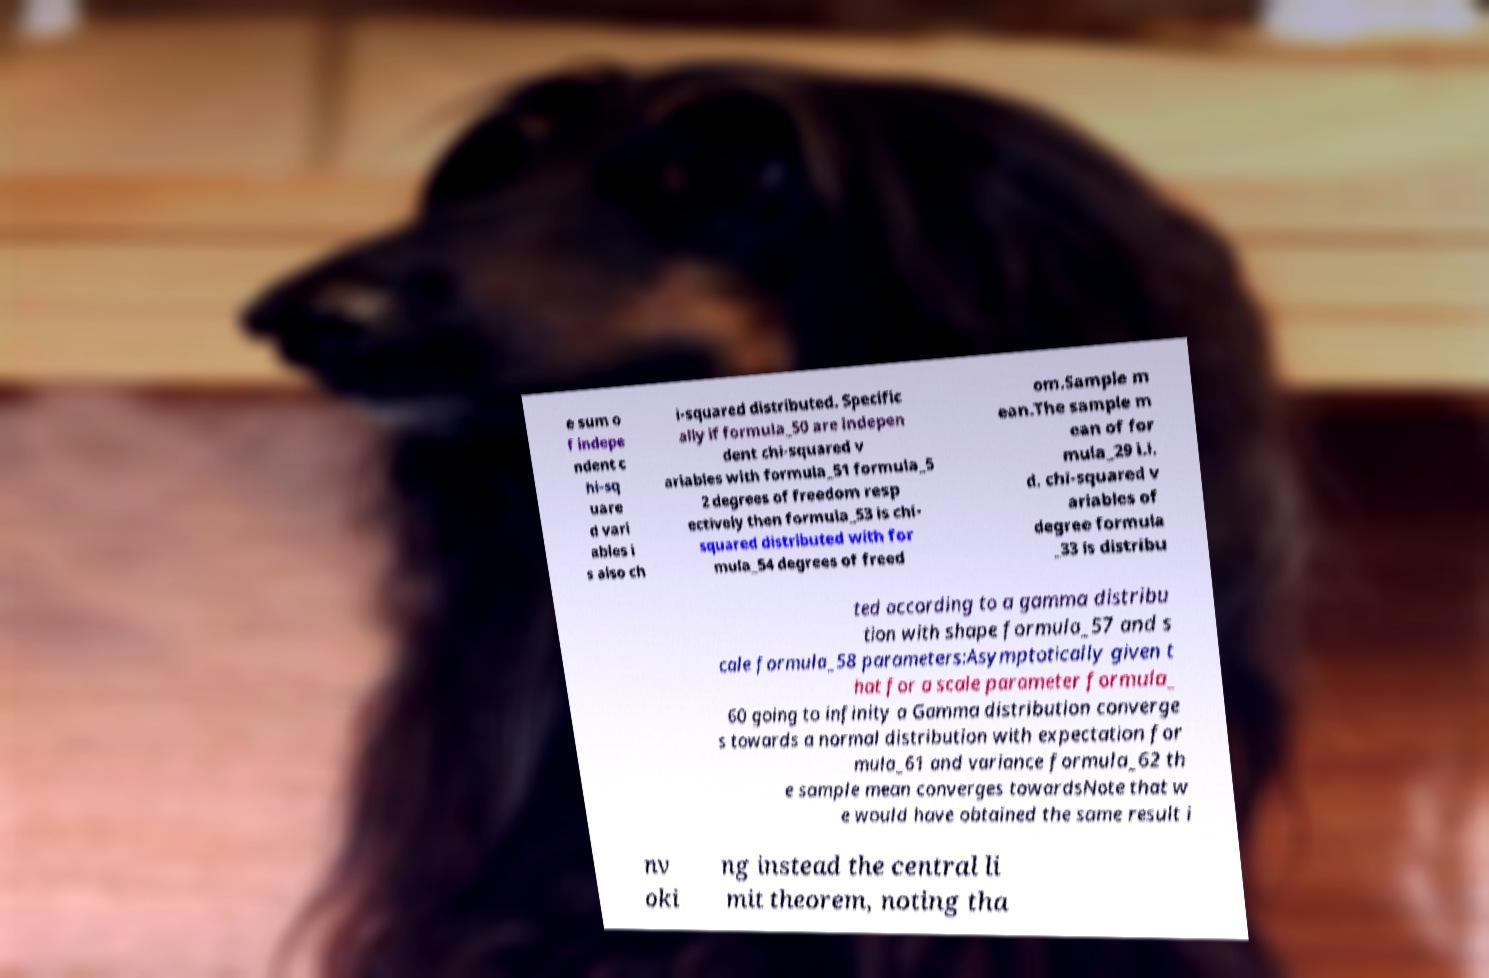Please read and relay the text visible in this image. What does it say? e sum o f indepe ndent c hi-sq uare d vari ables i s also ch i-squared distributed. Specific ally if formula_50 are indepen dent chi-squared v ariables with formula_51 formula_5 2 degrees of freedom resp ectively then formula_53 is chi- squared distributed with for mula_54 degrees of freed om.Sample m ean.The sample m ean of for mula_29 i.i. d. chi-squared v ariables of degree formula _33 is distribu ted according to a gamma distribu tion with shape formula_57 and s cale formula_58 parameters:Asymptotically given t hat for a scale parameter formula_ 60 going to infinity a Gamma distribution converge s towards a normal distribution with expectation for mula_61 and variance formula_62 th e sample mean converges towardsNote that w e would have obtained the same result i nv oki ng instead the central li mit theorem, noting tha 